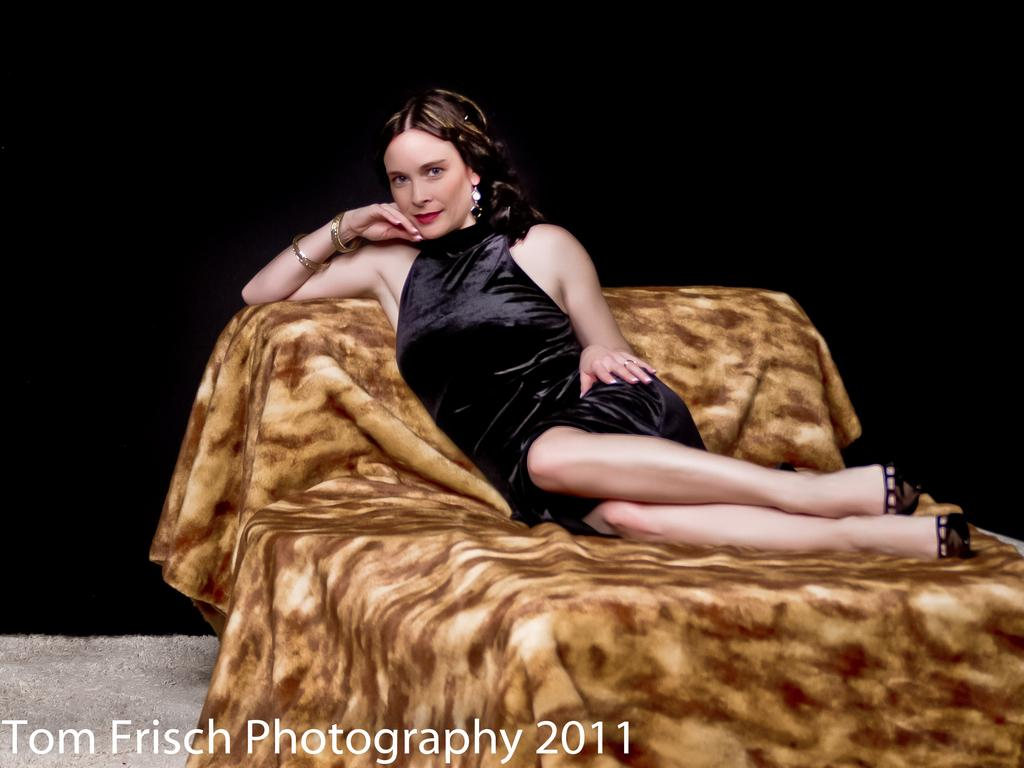What is the woman doing in the image? The woman is sitting on a bed in the image. How would you describe the lighting in the image? The background of the image is dark. Is there any additional information or branding present in the image? Yes, there is a watermark at the bottom of the image. What type of art is the woman creating in the image? There is no art or any indication of the woman creating art in the image. 